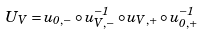Convert formula to latex. <formula><loc_0><loc_0><loc_500><loc_500>U _ { V } = u _ { 0 , - } \circ u _ { V , - } ^ { - 1 } \circ u _ { V , + } \circ u _ { 0 , + } ^ { - 1 }</formula> 